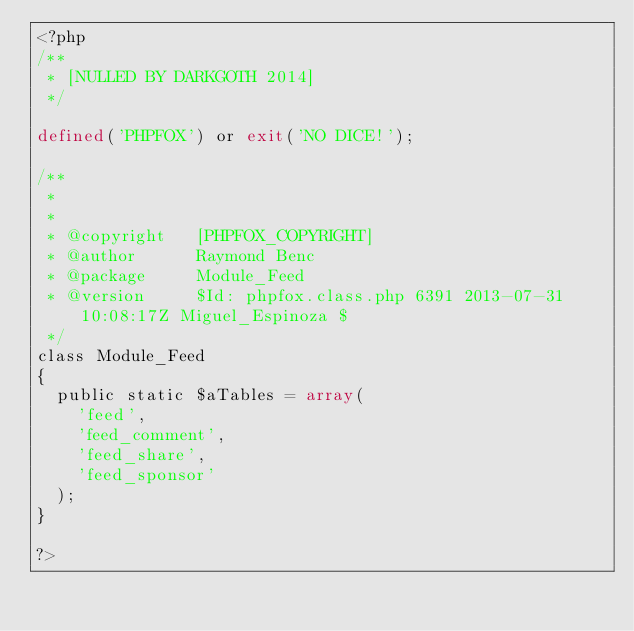<code> <loc_0><loc_0><loc_500><loc_500><_PHP_><?php
/**
 * [NULLED BY DARKGOTH 2014]
 */

defined('PHPFOX') or exit('NO DICE!');

/**
 * 
 * 
 * @copyright		[PHPFOX_COPYRIGHT]
 * @author  		Raymond Benc
 * @package  		Module_Feed
 * @version 		$Id: phpfox.class.php 6391 2013-07-31 10:08:17Z Miguel_Espinoza $
 */
class Module_Feed 
{	
	public static $aTables = array(
		'feed',
		'feed_comment',
		'feed_share',
		'feed_sponsor'
	);
}

?></code> 